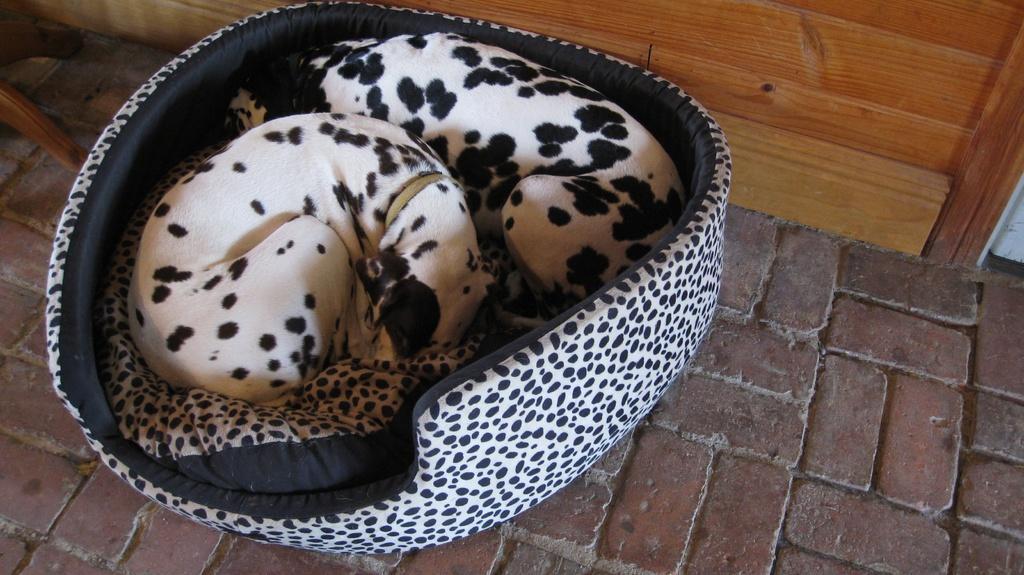How would you summarize this image in a sentence or two? In the picture we can see a tile bath on it, we can see a dog bed with two dogs are sleeping in it and the dogs are white in color with black dots to it and behind the bed we can see a wooden wall. 